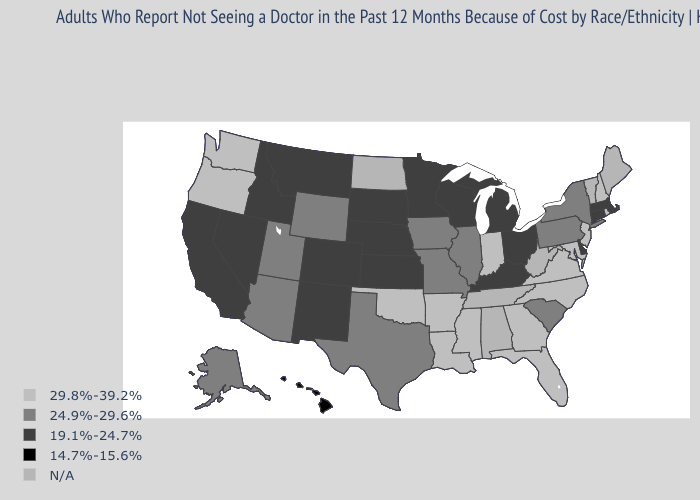What is the value of Arkansas?
Answer briefly. 29.8%-39.2%. Does the first symbol in the legend represent the smallest category?
Quick response, please. No. How many symbols are there in the legend?
Short answer required. 5. What is the value of Wyoming?
Be succinct. 24.9%-29.6%. Does Iowa have the lowest value in the MidWest?
Quick response, please. No. Name the states that have a value in the range N/A?
Quick response, please. Alabama, Maine, North Dakota, Tennessee, Vermont, West Virginia. What is the highest value in the Northeast ?
Short answer required. 29.8%-39.2%. Which states have the highest value in the USA?
Answer briefly. Arkansas, Florida, Georgia, Indiana, Louisiana, Maryland, Mississippi, New Hampshire, New Jersey, North Carolina, Oklahoma, Oregon, Rhode Island, Virginia, Washington. What is the lowest value in the USA?
Write a very short answer. 14.7%-15.6%. What is the lowest value in the USA?
Keep it brief. 14.7%-15.6%. Among the states that border Washington , which have the highest value?
Short answer required. Oregon. Name the states that have a value in the range 14.7%-15.6%?
Short answer required. Hawaii. 